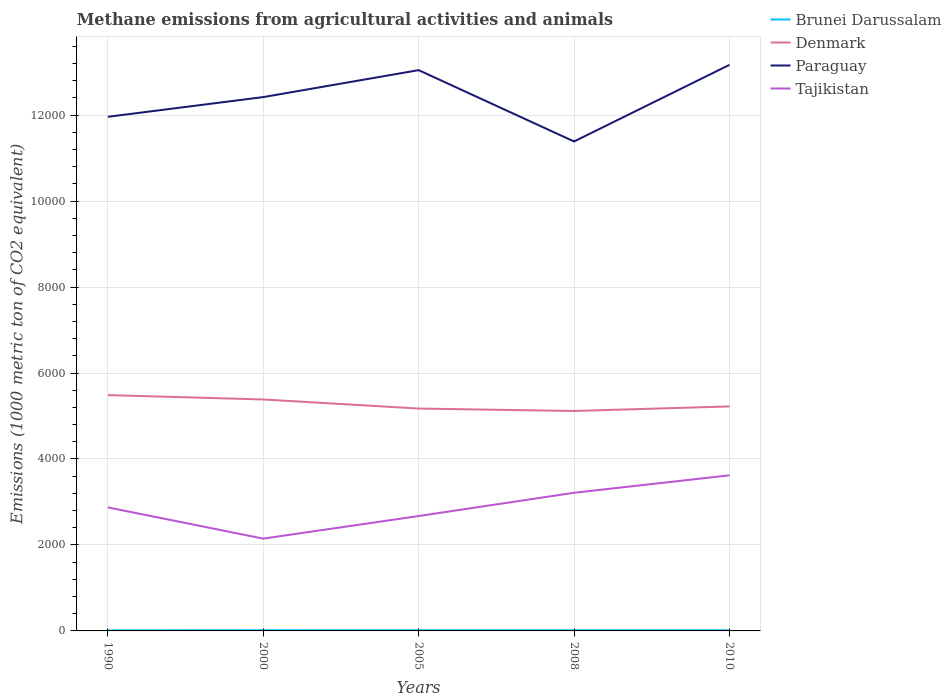How many different coloured lines are there?
Keep it short and to the point. 4. Does the line corresponding to Brunei Darussalam intersect with the line corresponding to Denmark?
Provide a short and direct response. No. Is the number of lines equal to the number of legend labels?
Provide a short and direct response. Yes. Across all years, what is the maximum amount of methane emitted in Paraguay?
Give a very brief answer. 1.14e+04. In which year was the amount of methane emitted in Paraguay maximum?
Your response must be concise. 2008. What is the total amount of methane emitted in Tajikistan in the graph?
Ensure brevity in your answer.  -525.5. What is the difference between the highest and the second highest amount of methane emitted in Brunei Darussalam?
Your answer should be compact. 2.8. What is the difference between the highest and the lowest amount of methane emitted in Paraguay?
Make the answer very short. 3. Does the graph contain any zero values?
Make the answer very short. No. Does the graph contain grids?
Make the answer very short. Yes. How many legend labels are there?
Your answer should be compact. 4. How are the legend labels stacked?
Give a very brief answer. Vertical. What is the title of the graph?
Your answer should be compact. Methane emissions from agricultural activities and animals. What is the label or title of the X-axis?
Ensure brevity in your answer.  Years. What is the label or title of the Y-axis?
Give a very brief answer. Emissions (1000 metric ton of CO2 equivalent). What is the Emissions (1000 metric ton of CO2 equivalent) of Brunei Darussalam in 1990?
Offer a terse response. 12.5. What is the Emissions (1000 metric ton of CO2 equivalent) in Denmark in 1990?
Provide a succinct answer. 5486.2. What is the Emissions (1000 metric ton of CO2 equivalent) in Paraguay in 1990?
Provide a succinct answer. 1.20e+04. What is the Emissions (1000 metric ton of CO2 equivalent) of Tajikistan in 1990?
Your response must be concise. 2874.3. What is the Emissions (1000 metric ton of CO2 equivalent) of Denmark in 2000?
Your answer should be compact. 5384.6. What is the Emissions (1000 metric ton of CO2 equivalent) of Paraguay in 2000?
Ensure brevity in your answer.  1.24e+04. What is the Emissions (1000 metric ton of CO2 equivalent) of Tajikistan in 2000?
Your response must be concise. 2147.2. What is the Emissions (1000 metric ton of CO2 equivalent) in Denmark in 2005?
Provide a short and direct response. 5173.5. What is the Emissions (1000 metric ton of CO2 equivalent) of Paraguay in 2005?
Ensure brevity in your answer.  1.30e+04. What is the Emissions (1000 metric ton of CO2 equivalent) in Tajikistan in 2005?
Your response must be concise. 2672.7. What is the Emissions (1000 metric ton of CO2 equivalent) of Denmark in 2008?
Keep it short and to the point. 5116.7. What is the Emissions (1000 metric ton of CO2 equivalent) of Paraguay in 2008?
Provide a succinct answer. 1.14e+04. What is the Emissions (1000 metric ton of CO2 equivalent) in Tajikistan in 2008?
Keep it short and to the point. 3214.1. What is the Emissions (1000 metric ton of CO2 equivalent) in Brunei Darussalam in 2010?
Keep it short and to the point. 14.4. What is the Emissions (1000 metric ton of CO2 equivalent) of Denmark in 2010?
Your answer should be very brief. 5222.8. What is the Emissions (1000 metric ton of CO2 equivalent) of Paraguay in 2010?
Keep it short and to the point. 1.32e+04. What is the Emissions (1000 metric ton of CO2 equivalent) in Tajikistan in 2010?
Offer a terse response. 3620.1. Across all years, what is the maximum Emissions (1000 metric ton of CO2 equivalent) of Denmark?
Keep it short and to the point. 5486.2. Across all years, what is the maximum Emissions (1000 metric ton of CO2 equivalent) in Paraguay?
Provide a succinct answer. 1.32e+04. Across all years, what is the maximum Emissions (1000 metric ton of CO2 equivalent) in Tajikistan?
Keep it short and to the point. 3620.1. Across all years, what is the minimum Emissions (1000 metric ton of CO2 equivalent) of Denmark?
Give a very brief answer. 5116.7. Across all years, what is the minimum Emissions (1000 metric ton of CO2 equivalent) in Paraguay?
Keep it short and to the point. 1.14e+04. Across all years, what is the minimum Emissions (1000 metric ton of CO2 equivalent) in Tajikistan?
Your response must be concise. 2147.2. What is the total Emissions (1000 metric ton of CO2 equivalent) in Brunei Darussalam in the graph?
Offer a very short reply. 70.6. What is the total Emissions (1000 metric ton of CO2 equivalent) in Denmark in the graph?
Offer a terse response. 2.64e+04. What is the total Emissions (1000 metric ton of CO2 equivalent) in Paraguay in the graph?
Offer a very short reply. 6.20e+04. What is the total Emissions (1000 metric ton of CO2 equivalent) in Tajikistan in the graph?
Keep it short and to the point. 1.45e+04. What is the difference between the Emissions (1000 metric ton of CO2 equivalent) of Denmark in 1990 and that in 2000?
Your answer should be compact. 101.6. What is the difference between the Emissions (1000 metric ton of CO2 equivalent) of Paraguay in 1990 and that in 2000?
Make the answer very short. -458.8. What is the difference between the Emissions (1000 metric ton of CO2 equivalent) of Tajikistan in 1990 and that in 2000?
Give a very brief answer. 727.1. What is the difference between the Emissions (1000 metric ton of CO2 equivalent) of Denmark in 1990 and that in 2005?
Give a very brief answer. 312.7. What is the difference between the Emissions (1000 metric ton of CO2 equivalent) of Paraguay in 1990 and that in 2005?
Your answer should be very brief. -1085.6. What is the difference between the Emissions (1000 metric ton of CO2 equivalent) in Tajikistan in 1990 and that in 2005?
Make the answer very short. 201.6. What is the difference between the Emissions (1000 metric ton of CO2 equivalent) in Brunei Darussalam in 1990 and that in 2008?
Provide a succinct answer. -1.8. What is the difference between the Emissions (1000 metric ton of CO2 equivalent) in Denmark in 1990 and that in 2008?
Ensure brevity in your answer.  369.5. What is the difference between the Emissions (1000 metric ton of CO2 equivalent) of Paraguay in 1990 and that in 2008?
Give a very brief answer. 573.8. What is the difference between the Emissions (1000 metric ton of CO2 equivalent) of Tajikistan in 1990 and that in 2008?
Make the answer very short. -339.8. What is the difference between the Emissions (1000 metric ton of CO2 equivalent) of Denmark in 1990 and that in 2010?
Offer a terse response. 263.4. What is the difference between the Emissions (1000 metric ton of CO2 equivalent) in Paraguay in 1990 and that in 2010?
Give a very brief answer. -1208.8. What is the difference between the Emissions (1000 metric ton of CO2 equivalent) of Tajikistan in 1990 and that in 2010?
Provide a short and direct response. -745.8. What is the difference between the Emissions (1000 metric ton of CO2 equivalent) of Denmark in 2000 and that in 2005?
Give a very brief answer. 211.1. What is the difference between the Emissions (1000 metric ton of CO2 equivalent) of Paraguay in 2000 and that in 2005?
Provide a short and direct response. -626.8. What is the difference between the Emissions (1000 metric ton of CO2 equivalent) of Tajikistan in 2000 and that in 2005?
Keep it short and to the point. -525.5. What is the difference between the Emissions (1000 metric ton of CO2 equivalent) in Denmark in 2000 and that in 2008?
Your answer should be very brief. 267.9. What is the difference between the Emissions (1000 metric ton of CO2 equivalent) in Paraguay in 2000 and that in 2008?
Your response must be concise. 1032.6. What is the difference between the Emissions (1000 metric ton of CO2 equivalent) in Tajikistan in 2000 and that in 2008?
Your answer should be compact. -1066.9. What is the difference between the Emissions (1000 metric ton of CO2 equivalent) of Brunei Darussalam in 2000 and that in 2010?
Keep it short and to the point. 0.9. What is the difference between the Emissions (1000 metric ton of CO2 equivalent) in Denmark in 2000 and that in 2010?
Keep it short and to the point. 161.8. What is the difference between the Emissions (1000 metric ton of CO2 equivalent) in Paraguay in 2000 and that in 2010?
Offer a very short reply. -750. What is the difference between the Emissions (1000 metric ton of CO2 equivalent) of Tajikistan in 2000 and that in 2010?
Your response must be concise. -1472.9. What is the difference between the Emissions (1000 metric ton of CO2 equivalent) of Denmark in 2005 and that in 2008?
Offer a terse response. 56.8. What is the difference between the Emissions (1000 metric ton of CO2 equivalent) in Paraguay in 2005 and that in 2008?
Provide a succinct answer. 1659.4. What is the difference between the Emissions (1000 metric ton of CO2 equivalent) in Tajikistan in 2005 and that in 2008?
Your answer should be very brief. -541.4. What is the difference between the Emissions (1000 metric ton of CO2 equivalent) of Denmark in 2005 and that in 2010?
Offer a terse response. -49.3. What is the difference between the Emissions (1000 metric ton of CO2 equivalent) in Paraguay in 2005 and that in 2010?
Your response must be concise. -123.2. What is the difference between the Emissions (1000 metric ton of CO2 equivalent) of Tajikistan in 2005 and that in 2010?
Your answer should be very brief. -947.4. What is the difference between the Emissions (1000 metric ton of CO2 equivalent) of Brunei Darussalam in 2008 and that in 2010?
Provide a succinct answer. -0.1. What is the difference between the Emissions (1000 metric ton of CO2 equivalent) of Denmark in 2008 and that in 2010?
Your response must be concise. -106.1. What is the difference between the Emissions (1000 metric ton of CO2 equivalent) in Paraguay in 2008 and that in 2010?
Your response must be concise. -1782.6. What is the difference between the Emissions (1000 metric ton of CO2 equivalent) of Tajikistan in 2008 and that in 2010?
Offer a very short reply. -406. What is the difference between the Emissions (1000 metric ton of CO2 equivalent) of Brunei Darussalam in 1990 and the Emissions (1000 metric ton of CO2 equivalent) of Denmark in 2000?
Offer a terse response. -5372.1. What is the difference between the Emissions (1000 metric ton of CO2 equivalent) of Brunei Darussalam in 1990 and the Emissions (1000 metric ton of CO2 equivalent) of Paraguay in 2000?
Ensure brevity in your answer.  -1.24e+04. What is the difference between the Emissions (1000 metric ton of CO2 equivalent) in Brunei Darussalam in 1990 and the Emissions (1000 metric ton of CO2 equivalent) in Tajikistan in 2000?
Your answer should be very brief. -2134.7. What is the difference between the Emissions (1000 metric ton of CO2 equivalent) of Denmark in 1990 and the Emissions (1000 metric ton of CO2 equivalent) of Paraguay in 2000?
Your answer should be very brief. -6933. What is the difference between the Emissions (1000 metric ton of CO2 equivalent) in Denmark in 1990 and the Emissions (1000 metric ton of CO2 equivalent) in Tajikistan in 2000?
Offer a terse response. 3339. What is the difference between the Emissions (1000 metric ton of CO2 equivalent) in Paraguay in 1990 and the Emissions (1000 metric ton of CO2 equivalent) in Tajikistan in 2000?
Provide a succinct answer. 9813.2. What is the difference between the Emissions (1000 metric ton of CO2 equivalent) of Brunei Darussalam in 1990 and the Emissions (1000 metric ton of CO2 equivalent) of Denmark in 2005?
Ensure brevity in your answer.  -5161. What is the difference between the Emissions (1000 metric ton of CO2 equivalent) of Brunei Darussalam in 1990 and the Emissions (1000 metric ton of CO2 equivalent) of Paraguay in 2005?
Your response must be concise. -1.30e+04. What is the difference between the Emissions (1000 metric ton of CO2 equivalent) in Brunei Darussalam in 1990 and the Emissions (1000 metric ton of CO2 equivalent) in Tajikistan in 2005?
Your answer should be very brief. -2660.2. What is the difference between the Emissions (1000 metric ton of CO2 equivalent) in Denmark in 1990 and the Emissions (1000 metric ton of CO2 equivalent) in Paraguay in 2005?
Provide a succinct answer. -7559.8. What is the difference between the Emissions (1000 metric ton of CO2 equivalent) of Denmark in 1990 and the Emissions (1000 metric ton of CO2 equivalent) of Tajikistan in 2005?
Provide a short and direct response. 2813.5. What is the difference between the Emissions (1000 metric ton of CO2 equivalent) in Paraguay in 1990 and the Emissions (1000 metric ton of CO2 equivalent) in Tajikistan in 2005?
Provide a succinct answer. 9287.7. What is the difference between the Emissions (1000 metric ton of CO2 equivalent) of Brunei Darussalam in 1990 and the Emissions (1000 metric ton of CO2 equivalent) of Denmark in 2008?
Ensure brevity in your answer.  -5104.2. What is the difference between the Emissions (1000 metric ton of CO2 equivalent) in Brunei Darussalam in 1990 and the Emissions (1000 metric ton of CO2 equivalent) in Paraguay in 2008?
Make the answer very short. -1.14e+04. What is the difference between the Emissions (1000 metric ton of CO2 equivalent) in Brunei Darussalam in 1990 and the Emissions (1000 metric ton of CO2 equivalent) in Tajikistan in 2008?
Provide a succinct answer. -3201.6. What is the difference between the Emissions (1000 metric ton of CO2 equivalent) in Denmark in 1990 and the Emissions (1000 metric ton of CO2 equivalent) in Paraguay in 2008?
Keep it short and to the point. -5900.4. What is the difference between the Emissions (1000 metric ton of CO2 equivalent) in Denmark in 1990 and the Emissions (1000 metric ton of CO2 equivalent) in Tajikistan in 2008?
Provide a succinct answer. 2272.1. What is the difference between the Emissions (1000 metric ton of CO2 equivalent) of Paraguay in 1990 and the Emissions (1000 metric ton of CO2 equivalent) of Tajikistan in 2008?
Your answer should be compact. 8746.3. What is the difference between the Emissions (1000 metric ton of CO2 equivalent) in Brunei Darussalam in 1990 and the Emissions (1000 metric ton of CO2 equivalent) in Denmark in 2010?
Your response must be concise. -5210.3. What is the difference between the Emissions (1000 metric ton of CO2 equivalent) of Brunei Darussalam in 1990 and the Emissions (1000 metric ton of CO2 equivalent) of Paraguay in 2010?
Your answer should be compact. -1.32e+04. What is the difference between the Emissions (1000 metric ton of CO2 equivalent) in Brunei Darussalam in 1990 and the Emissions (1000 metric ton of CO2 equivalent) in Tajikistan in 2010?
Provide a short and direct response. -3607.6. What is the difference between the Emissions (1000 metric ton of CO2 equivalent) of Denmark in 1990 and the Emissions (1000 metric ton of CO2 equivalent) of Paraguay in 2010?
Provide a succinct answer. -7683. What is the difference between the Emissions (1000 metric ton of CO2 equivalent) of Denmark in 1990 and the Emissions (1000 metric ton of CO2 equivalent) of Tajikistan in 2010?
Keep it short and to the point. 1866.1. What is the difference between the Emissions (1000 metric ton of CO2 equivalent) in Paraguay in 1990 and the Emissions (1000 metric ton of CO2 equivalent) in Tajikistan in 2010?
Ensure brevity in your answer.  8340.3. What is the difference between the Emissions (1000 metric ton of CO2 equivalent) of Brunei Darussalam in 2000 and the Emissions (1000 metric ton of CO2 equivalent) of Denmark in 2005?
Your answer should be compact. -5158.2. What is the difference between the Emissions (1000 metric ton of CO2 equivalent) of Brunei Darussalam in 2000 and the Emissions (1000 metric ton of CO2 equivalent) of Paraguay in 2005?
Offer a terse response. -1.30e+04. What is the difference between the Emissions (1000 metric ton of CO2 equivalent) in Brunei Darussalam in 2000 and the Emissions (1000 metric ton of CO2 equivalent) in Tajikistan in 2005?
Offer a terse response. -2657.4. What is the difference between the Emissions (1000 metric ton of CO2 equivalent) in Denmark in 2000 and the Emissions (1000 metric ton of CO2 equivalent) in Paraguay in 2005?
Your answer should be very brief. -7661.4. What is the difference between the Emissions (1000 metric ton of CO2 equivalent) of Denmark in 2000 and the Emissions (1000 metric ton of CO2 equivalent) of Tajikistan in 2005?
Provide a short and direct response. 2711.9. What is the difference between the Emissions (1000 metric ton of CO2 equivalent) of Paraguay in 2000 and the Emissions (1000 metric ton of CO2 equivalent) of Tajikistan in 2005?
Provide a succinct answer. 9746.5. What is the difference between the Emissions (1000 metric ton of CO2 equivalent) of Brunei Darussalam in 2000 and the Emissions (1000 metric ton of CO2 equivalent) of Denmark in 2008?
Ensure brevity in your answer.  -5101.4. What is the difference between the Emissions (1000 metric ton of CO2 equivalent) of Brunei Darussalam in 2000 and the Emissions (1000 metric ton of CO2 equivalent) of Paraguay in 2008?
Provide a succinct answer. -1.14e+04. What is the difference between the Emissions (1000 metric ton of CO2 equivalent) in Brunei Darussalam in 2000 and the Emissions (1000 metric ton of CO2 equivalent) in Tajikistan in 2008?
Your answer should be compact. -3198.8. What is the difference between the Emissions (1000 metric ton of CO2 equivalent) of Denmark in 2000 and the Emissions (1000 metric ton of CO2 equivalent) of Paraguay in 2008?
Ensure brevity in your answer.  -6002. What is the difference between the Emissions (1000 metric ton of CO2 equivalent) of Denmark in 2000 and the Emissions (1000 metric ton of CO2 equivalent) of Tajikistan in 2008?
Give a very brief answer. 2170.5. What is the difference between the Emissions (1000 metric ton of CO2 equivalent) in Paraguay in 2000 and the Emissions (1000 metric ton of CO2 equivalent) in Tajikistan in 2008?
Keep it short and to the point. 9205.1. What is the difference between the Emissions (1000 metric ton of CO2 equivalent) of Brunei Darussalam in 2000 and the Emissions (1000 metric ton of CO2 equivalent) of Denmark in 2010?
Your response must be concise. -5207.5. What is the difference between the Emissions (1000 metric ton of CO2 equivalent) in Brunei Darussalam in 2000 and the Emissions (1000 metric ton of CO2 equivalent) in Paraguay in 2010?
Your response must be concise. -1.32e+04. What is the difference between the Emissions (1000 metric ton of CO2 equivalent) in Brunei Darussalam in 2000 and the Emissions (1000 metric ton of CO2 equivalent) in Tajikistan in 2010?
Give a very brief answer. -3604.8. What is the difference between the Emissions (1000 metric ton of CO2 equivalent) in Denmark in 2000 and the Emissions (1000 metric ton of CO2 equivalent) in Paraguay in 2010?
Your answer should be very brief. -7784.6. What is the difference between the Emissions (1000 metric ton of CO2 equivalent) in Denmark in 2000 and the Emissions (1000 metric ton of CO2 equivalent) in Tajikistan in 2010?
Your answer should be compact. 1764.5. What is the difference between the Emissions (1000 metric ton of CO2 equivalent) in Paraguay in 2000 and the Emissions (1000 metric ton of CO2 equivalent) in Tajikistan in 2010?
Your response must be concise. 8799.1. What is the difference between the Emissions (1000 metric ton of CO2 equivalent) of Brunei Darussalam in 2005 and the Emissions (1000 metric ton of CO2 equivalent) of Denmark in 2008?
Your response must be concise. -5102.6. What is the difference between the Emissions (1000 metric ton of CO2 equivalent) in Brunei Darussalam in 2005 and the Emissions (1000 metric ton of CO2 equivalent) in Paraguay in 2008?
Make the answer very short. -1.14e+04. What is the difference between the Emissions (1000 metric ton of CO2 equivalent) of Brunei Darussalam in 2005 and the Emissions (1000 metric ton of CO2 equivalent) of Tajikistan in 2008?
Your response must be concise. -3200. What is the difference between the Emissions (1000 metric ton of CO2 equivalent) in Denmark in 2005 and the Emissions (1000 metric ton of CO2 equivalent) in Paraguay in 2008?
Provide a succinct answer. -6213.1. What is the difference between the Emissions (1000 metric ton of CO2 equivalent) in Denmark in 2005 and the Emissions (1000 metric ton of CO2 equivalent) in Tajikistan in 2008?
Provide a short and direct response. 1959.4. What is the difference between the Emissions (1000 metric ton of CO2 equivalent) of Paraguay in 2005 and the Emissions (1000 metric ton of CO2 equivalent) of Tajikistan in 2008?
Ensure brevity in your answer.  9831.9. What is the difference between the Emissions (1000 metric ton of CO2 equivalent) of Brunei Darussalam in 2005 and the Emissions (1000 metric ton of CO2 equivalent) of Denmark in 2010?
Give a very brief answer. -5208.7. What is the difference between the Emissions (1000 metric ton of CO2 equivalent) of Brunei Darussalam in 2005 and the Emissions (1000 metric ton of CO2 equivalent) of Paraguay in 2010?
Provide a short and direct response. -1.32e+04. What is the difference between the Emissions (1000 metric ton of CO2 equivalent) in Brunei Darussalam in 2005 and the Emissions (1000 metric ton of CO2 equivalent) in Tajikistan in 2010?
Give a very brief answer. -3606. What is the difference between the Emissions (1000 metric ton of CO2 equivalent) in Denmark in 2005 and the Emissions (1000 metric ton of CO2 equivalent) in Paraguay in 2010?
Give a very brief answer. -7995.7. What is the difference between the Emissions (1000 metric ton of CO2 equivalent) in Denmark in 2005 and the Emissions (1000 metric ton of CO2 equivalent) in Tajikistan in 2010?
Keep it short and to the point. 1553.4. What is the difference between the Emissions (1000 metric ton of CO2 equivalent) of Paraguay in 2005 and the Emissions (1000 metric ton of CO2 equivalent) of Tajikistan in 2010?
Offer a very short reply. 9425.9. What is the difference between the Emissions (1000 metric ton of CO2 equivalent) in Brunei Darussalam in 2008 and the Emissions (1000 metric ton of CO2 equivalent) in Denmark in 2010?
Give a very brief answer. -5208.5. What is the difference between the Emissions (1000 metric ton of CO2 equivalent) of Brunei Darussalam in 2008 and the Emissions (1000 metric ton of CO2 equivalent) of Paraguay in 2010?
Offer a terse response. -1.32e+04. What is the difference between the Emissions (1000 metric ton of CO2 equivalent) of Brunei Darussalam in 2008 and the Emissions (1000 metric ton of CO2 equivalent) of Tajikistan in 2010?
Your answer should be compact. -3605.8. What is the difference between the Emissions (1000 metric ton of CO2 equivalent) of Denmark in 2008 and the Emissions (1000 metric ton of CO2 equivalent) of Paraguay in 2010?
Make the answer very short. -8052.5. What is the difference between the Emissions (1000 metric ton of CO2 equivalent) of Denmark in 2008 and the Emissions (1000 metric ton of CO2 equivalent) of Tajikistan in 2010?
Offer a terse response. 1496.6. What is the difference between the Emissions (1000 metric ton of CO2 equivalent) of Paraguay in 2008 and the Emissions (1000 metric ton of CO2 equivalent) of Tajikistan in 2010?
Offer a very short reply. 7766.5. What is the average Emissions (1000 metric ton of CO2 equivalent) of Brunei Darussalam per year?
Provide a short and direct response. 14.12. What is the average Emissions (1000 metric ton of CO2 equivalent) in Denmark per year?
Ensure brevity in your answer.  5276.76. What is the average Emissions (1000 metric ton of CO2 equivalent) of Paraguay per year?
Offer a terse response. 1.24e+04. What is the average Emissions (1000 metric ton of CO2 equivalent) of Tajikistan per year?
Your answer should be very brief. 2905.68. In the year 1990, what is the difference between the Emissions (1000 metric ton of CO2 equivalent) in Brunei Darussalam and Emissions (1000 metric ton of CO2 equivalent) in Denmark?
Offer a terse response. -5473.7. In the year 1990, what is the difference between the Emissions (1000 metric ton of CO2 equivalent) in Brunei Darussalam and Emissions (1000 metric ton of CO2 equivalent) in Paraguay?
Your answer should be very brief. -1.19e+04. In the year 1990, what is the difference between the Emissions (1000 metric ton of CO2 equivalent) in Brunei Darussalam and Emissions (1000 metric ton of CO2 equivalent) in Tajikistan?
Provide a short and direct response. -2861.8. In the year 1990, what is the difference between the Emissions (1000 metric ton of CO2 equivalent) in Denmark and Emissions (1000 metric ton of CO2 equivalent) in Paraguay?
Offer a very short reply. -6474.2. In the year 1990, what is the difference between the Emissions (1000 metric ton of CO2 equivalent) of Denmark and Emissions (1000 metric ton of CO2 equivalent) of Tajikistan?
Your answer should be very brief. 2611.9. In the year 1990, what is the difference between the Emissions (1000 metric ton of CO2 equivalent) in Paraguay and Emissions (1000 metric ton of CO2 equivalent) in Tajikistan?
Provide a short and direct response. 9086.1. In the year 2000, what is the difference between the Emissions (1000 metric ton of CO2 equivalent) in Brunei Darussalam and Emissions (1000 metric ton of CO2 equivalent) in Denmark?
Your answer should be compact. -5369.3. In the year 2000, what is the difference between the Emissions (1000 metric ton of CO2 equivalent) in Brunei Darussalam and Emissions (1000 metric ton of CO2 equivalent) in Paraguay?
Make the answer very short. -1.24e+04. In the year 2000, what is the difference between the Emissions (1000 metric ton of CO2 equivalent) of Brunei Darussalam and Emissions (1000 metric ton of CO2 equivalent) of Tajikistan?
Your answer should be compact. -2131.9. In the year 2000, what is the difference between the Emissions (1000 metric ton of CO2 equivalent) of Denmark and Emissions (1000 metric ton of CO2 equivalent) of Paraguay?
Your answer should be compact. -7034.6. In the year 2000, what is the difference between the Emissions (1000 metric ton of CO2 equivalent) in Denmark and Emissions (1000 metric ton of CO2 equivalent) in Tajikistan?
Offer a terse response. 3237.4. In the year 2000, what is the difference between the Emissions (1000 metric ton of CO2 equivalent) in Paraguay and Emissions (1000 metric ton of CO2 equivalent) in Tajikistan?
Give a very brief answer. 1.03e+04. In the year 2005, what is the difference between the Emissions (1000 metric ton of CO2 equivalent) of Brunei Darussalam and Emissions (1000 metric ton of CO2 equivalent) of Denmark?
Provide a succinct answer. -5159.4. In the year 2005, what is the difference between the Emissions (1000 metric ton of CO2 equivalent) of Brunei Darussalam and Emissions (1000 metric ton of CO2 equivalent) of Paraguay?
Make the answer very short. -1.30e+04. In the year 2005, what is the difference between the Emissions (1000 metric ton of CO2 equivalent) of Brunei Darussalam and Emissions (1000 metric ton of CO2 equivalent) of Tajikistan?
Provide a succinct answer. -2658.6. In the year 2005, what is the difference between the Emissions (1000 metric ton of CO2 equivalent) of Denmark and Emissions (1000 metric ton of CO2 equivalent) of Paraguay?
Keep it short and to the point. -7872.5. In the year 2005, what is the difference between the Emissions (1000 metric ton of CO2 equivalent) in Denmark and Emissions (1000 metric ton of CO2 equivalent) in Tajikistan?
Give a very brief answer. 2500.8. In the year 2005, what is the difference between the Emissions (1000 metric ton of CO2 equivalent) in Paraguay and Emissions (1000 metric ton of CO2 equivalent) in Tajikistan?
Provide a short and direct response. 1.04e+04. In the year 2008, what is the difference between the Emissions (1000 metric ton of CO2 equivalent) in Brunei Darussalam and Emissions (1000 metric ton of CO2 equivalent) in Denmark?
Give a very brief answer. -5102.4. In the year 2008, what is the difference between the Emissions (1000 metric ton of CO2 equivalent) in Brunei Darussalam and Emissions (1000 metric ton of CO2 equivalent) in Paraguay?
Offer a terse response. -1.14e+04. In the year 2008, what is the difference between the Emissions (1000 metric ton of CO2 equivalent) in Brunei Darussalam and Emissions (1000 metric ton of CO2 equivalent) in Tajikistan?
Offer a terse response. -3199.8. In the year 2008, what is the difference between the Emissions (1000 metric ton of CO2 equivalent) in Denmark and Emissions (1000 metric ton of CO2 equivalent) in Paraguay?
Your answer should be very brief. -6269.9. In the year 2008, what is the difference between the Emissions (1000 metric ton of CO2 equivalent) of Denmark and Emissions (1000 metric ton of CO2 equivalent) of Tajikistan?
Provide a succinct answer. 1902.6. In the year 2008, what is the difference between the Emissions (1000 metric ton of CO2 equivalent) in Paraguay and Emissions (1000 metric ton of CO2 equivalent) in Tajikistan?
Provide a succinct answer. 8172.5. In the year 2010, what is the difference between the Emissions (1000 metric ton of CO2 equivalent) in Brunei Darussalam and Emissions (1000 metric ton of CO2 equivalent) in Denmark?
Keep it short and to the point. -5208.4. In the year 2010, what is the difference between the Emissions (1000 metric ton of CO2 equivalent) in Brunei Darussalam and Emissions (1000 metric ton of CO2 equivalent) in Paraguay?
Your response must be concise. -1.32e+04. In the year 2010, what is the difference between the Emissions (1000 metric ton of CO2 equivalent) in Brunei Darussalam and Emissions (1000 metric ton of CO2 equivalent) in Tajikistan?
Offer a very short reply. -3605.7. In the year 2010, what is the difference between the Emissions (1000 metric ton of CO2 equivalent) of Denmark and Emissions (1000 metric ton of CO2 equivalent) of Paraguay?
Make the answer very short. -7946.4. In the year 2010, what is the difference between the Emissions (1000 metric ton of CO2 equivalent) of Denmark and Emissions (1000 metric ton of CO2 equivalent) of Tajikistan?
Make the answer very short. 1602.7. In the year 2010, what is the difference between the Emissions (1000 metric ton of CO2 equivalent) of Paraguay and Emissions (1000 metric ton of CO2 equivalent) of Tajikistan?
Give a very brief answer. 9549.1. What is the ratio of the Emissions (1000 metric ton of CO2 equivalent) of Brunei Darussalam in 1990 to that in 2000?
Offer a terse response. 0.82. What is the ratio of the Emissions (1000 metric ton of CO2 equivalent) in Denmark in 1990 to that in 2000?
Provide a short and direct response. 1.02. What is the ratio of the Emissions (1000 metric ton of CO2 equivalent) of Paraguay in 1990 to that in 2000?
Give a very brief answer. 0.96. What is the ratio of the Emissions (1000 metric ton of CO2 equivalent) in Tajikistan in 1990 to that in 2000?
Make the answer very short. 1.34. What is the ratio of the Emissions (1000 metric ton of CO2 equivalent) in Brunei Darussalam in 1990 to that in 2005?
Provide a succinct answer. 0.89. What is the ratio of the Emissions (1000 metric ton of CO2 equivalent) of Denmark in 1990 to that in 2005?
Keep it short and to the point. 1.06. What is the ratio of the Emissions (1000 metric ton of CO2 equivalent) of Paraguay in 1990 to that in 2005?
Ensure brevity in your answer.  0.92. What is the ratio of the Emissions (1000 metric ton of CO2 equivalent) in Tajikistan in 1990 to that in 2005?
Your answer should be compact. 1.08. What is the ratio of the Emissions (1000 metric ton of CO2 equivalent) of Brunei Darussalam in 1990 to that in 2008?
Your answer should be very brief. 0.87. What is the ratio of the Emissions (1000 metric ton of CO2 equivalent) in Denmark in 1990 to that in 2008?
Provide a succinct answer. 1.07. What is the ratio of the Emissions (1000 metric ton of CO2 equivalent) in Paraguay in 1990 to that in 2008?
Ensure brevity in your answer.  1.05. What is the ratio of the Emissions (1000 metric ton of CO2 equivalent) in Tajikistan in 1990 to that in 2008?
Provide a short and direct response. 0.89. What is the ratio of the Emissions (1000 metric ton of CO2 equivalent) of Brunei Darussalam in 1990 to that in 2010?
Offer a terse response. 0.87. What is the ratio of the Emissions (1000 metric ton of CO2 equivalent) in Denmark in 1990 to that in 2010?
Your answer should be compact. 1.05. What is the ratio of the Emissions (1000 metric ton of CO2 equivalent) in Paraguay in 1990 to that in 2010?
Keep it short and to the point. 0.91. What is the ratio of the Emissions (1000 metric ton of CO2 equivalent) in Tajikistan in 1990 to that in 2010?
Ensure brevity in your answer.  0.79. What is the ratio of the Emissions (1000 metric ton of CO2 equivalent) of Brunei Darussalam in 2000 to that in 2005?
Offer a terse response. 1.09. What is the ratio of the Emissions (1000 metric ton of CO2 equivalent) in Denmark in 2000 to that in 2005?
Offer a terse response. 1.04. What is the ratio of the Emissions (1000 metric ton of CO2 equivalent) of Paraguay in 2000 to that in 2005?
Your answer should be very brief. 0.95. What is the ratio of the Emissions (1000 metric ton of CO2 equivalent) of Tajikistan in 2000 to that in 2005?
Keep it short and to the point. 0.8. What is the ratio of the Emissions (1000 metric ton of CO2 equivalent) of Brunei Darussalam in 2000 to that in 2008?
Ensure brevity in your answer.  1.07. What is the ratio of the Emissions (1000 metric ton of CO2 equivalent) in Denmark in 2000 to that in 2008?
Keep it short and to the point. 1.05. What is the ratio of the Emissions (1000 metric ton of CO2 equivalent) of Paraguay in 2000 to that in 2008?
Give a very brief answer. 1.09. What is the ratio of the Emissions (1000 metric ton of CO2 equivalent) in Tajikistan in 2000 to that in 2008?
Give a very brief answer. 0.67. What is the ratio of the Emissions (1000 metric ton of CO2 equivalent) in Denmark in 2000 to that in 2010?
Provide a succinct answer. 1.03. What is the ratio of the Emissions (1000 metric ton of CO2 equivalent) of Paraguay in 2000 to that in 2010?
Provide a short and direct response. 0.94. What is the ratio of the Emissions (1000 metric ton of CO2 equivalent) of Tajikistan in 2000 to that in 2010?
Offer a very short reply. 0.59. What is the ratio of the Emissions (1000 metric ton of CO2 equivalent) in Brunei Darussalam in 2005 to that in 2008?
Give a very brief answer. 0.99. What is the ratio of the Emissions (1000 metric ton of CO2 equivalent) in Denmark in 2005 to that in 2008?
Provide a short and direct response. 1.01. What is the ratio of the Emissions (1000 metric ton of CO2 equivalent) in Paraguay in 2005 to that in 2008?
Your answer should be very brief. 1.15. What is the ratio of the Emissions (1000 metric ton of CO2 equivalent) in Tajikistan in 2005 to that in 2008?
Your answer should be very brief. 0.83. What is the ratio of the Emissions (1000 metric ton of CO2 equivalent) of Brunei Darussalam in 2005 to that in 2010?
Keep it short and to the point. 0.98. What is the ratio of the Emissions (1000 metric ton of CO2 equivalent) in Denmark in 2005 to that in 2010?
Give a very brief answer. 0.99. What is the ratio of the Emissions (1000 metric ton of CO2 equivalent) of Paraguay in 2005 to that in 2010?
Offer a very short reply. 0.99. What is the ratio of the Emissions (1000 metric ton of CO2 equivalent) in Tajikistan in 2005 to that in 2010?
Your response must be concise. 0.74. What is the ratio of the Emissions (1000 metric ton of CO2 equivalent) of Denmark in 2008 to that in 2010?
Ensure brevity in your answer.  0.98. What is the ratio of the Emissions (1000 metric ton of CO2 equivalent) of Paraguay in 2008 to that in 2010?
Provide a succinct answer. 0.86. What is the ratio of the Emissions (1000 metric ton of CO2 equivalent) of Tajikistan in 2008 to that in 2010?
Your response must be concise. 0.89. What is the difference between the highest and the second highest Emissions (1000 metric ton of CO2 equivalent) in Denmark?
Provide a short and direct response. 101.6. What is the difference between the highest and the second highest Emissions (1000 metric ton of CO2 equivalent) of Paraguay?
Your response must be concise. 123.2. What is the difference between the highest and the second highest Emissions (1000 metric ton of CO2 equivalent) of Tajikistan?
Ensure brevity in your answer.  406. What is the difference between the highest and the lowest Emissions (1000 metric ton of CO2 equivalent) of Brunei Darussalam?
Ensure brevity in your answer.  2.8. What is the difference between the highest and the lowest Emissions (1000 metric ton of CO2 equivalent) in Denmark?
Keep it short and to the point. 369.5. What is the difference between the highest and the lowest Emissions (1000 metric ton of CO2 equivalent) in Paraguay?
Offer a terse response. 1782.6. What is the difference between the highest and the lowest Emissions (1000 metric ton of CO2 equivalent) of Tajikistan?
Offer a very short reply. 1472.9. 